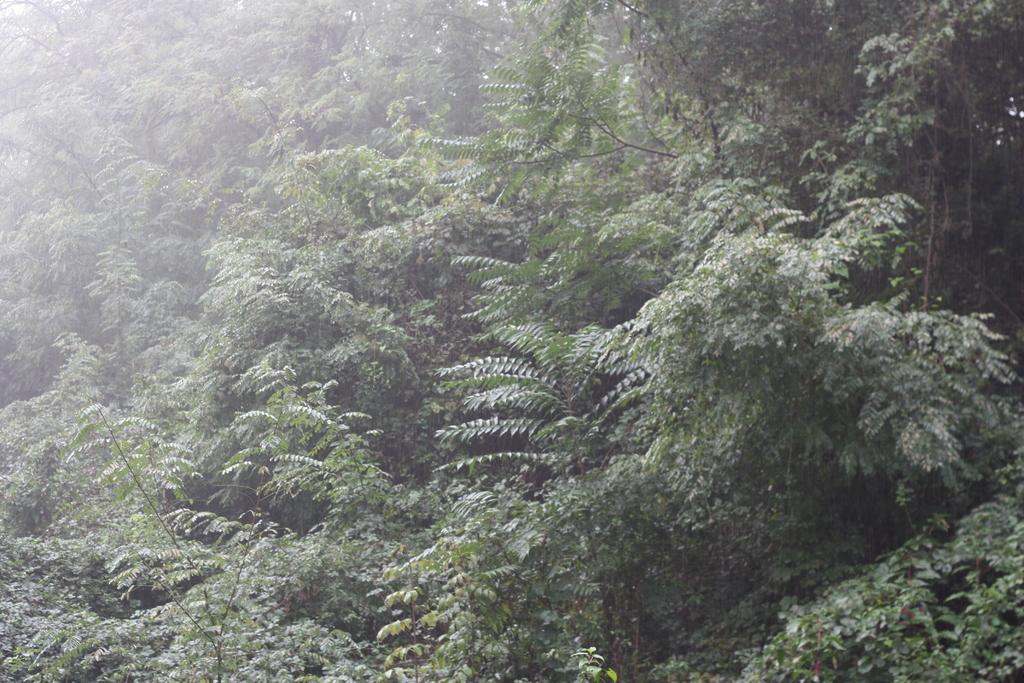What type of vegetation is present in the image? There are many trees in the image. What features can be observed on the trees? The trees have branches and leaves. What type of committee is responsible for the development of the trees in the image? There is no committee or development process mentioned in the image; it simply shows trees with branches and leaves. 